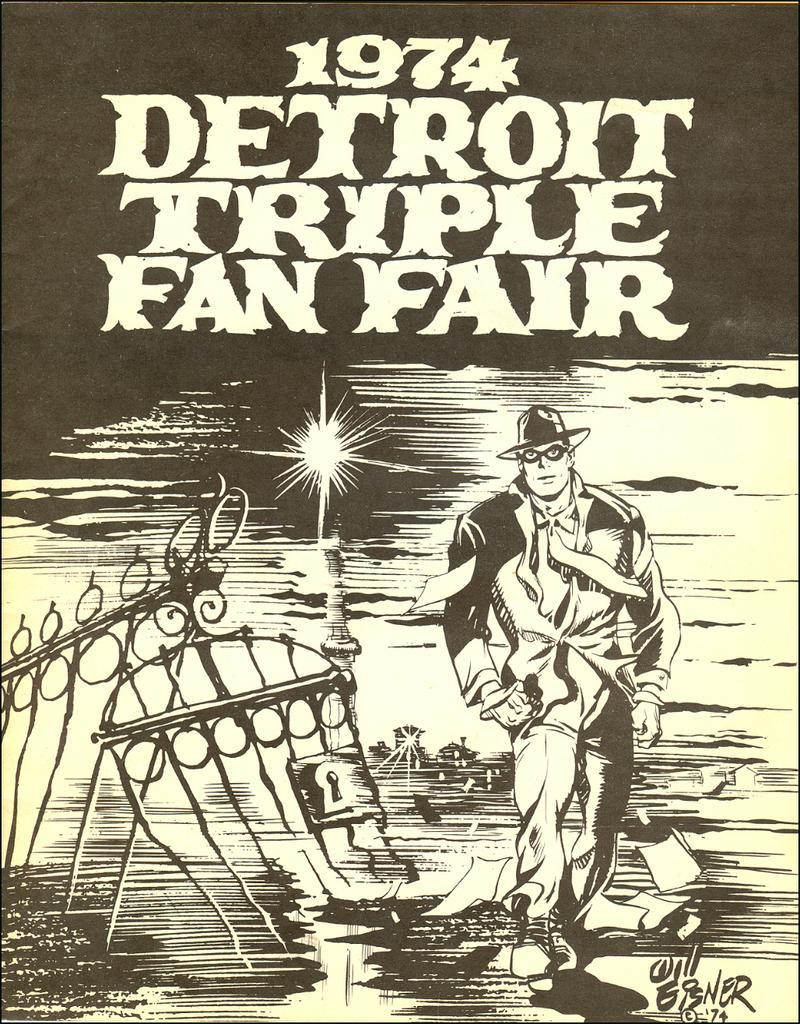Describe this image in one or two sentences. This is a picture of a poster. In this picture we can see objects, numbers, letters and we can see a man wearing a hat and goggles. 